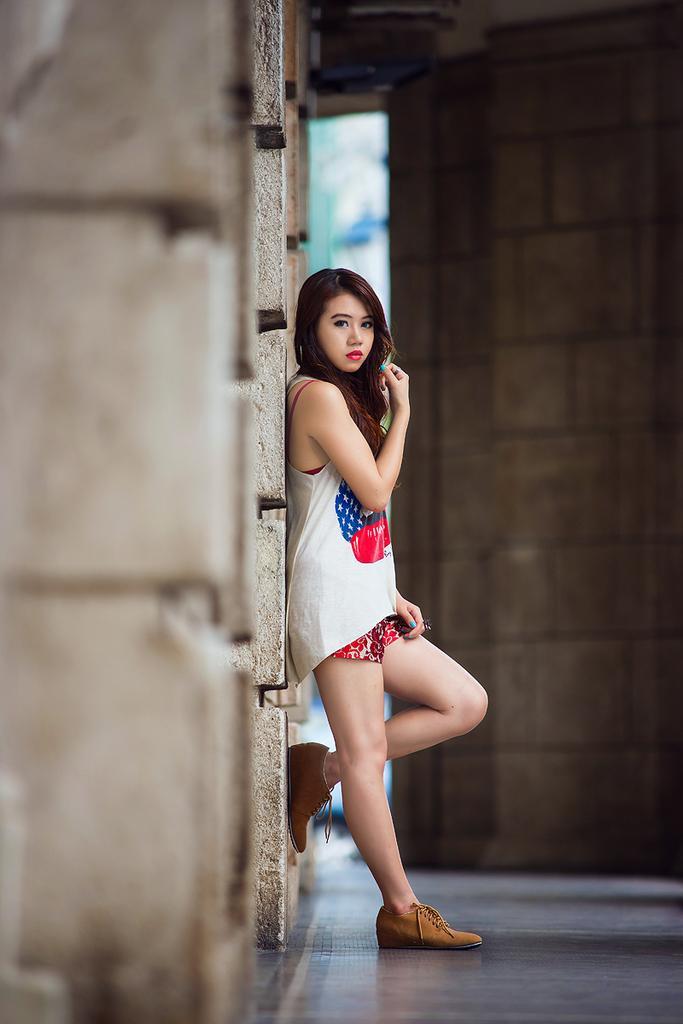In one or two sentences, can you explain what this image depicts? In this image a beautiful girl standing and she is wearing a white T-shirt,she is wearing a brown shoes. 